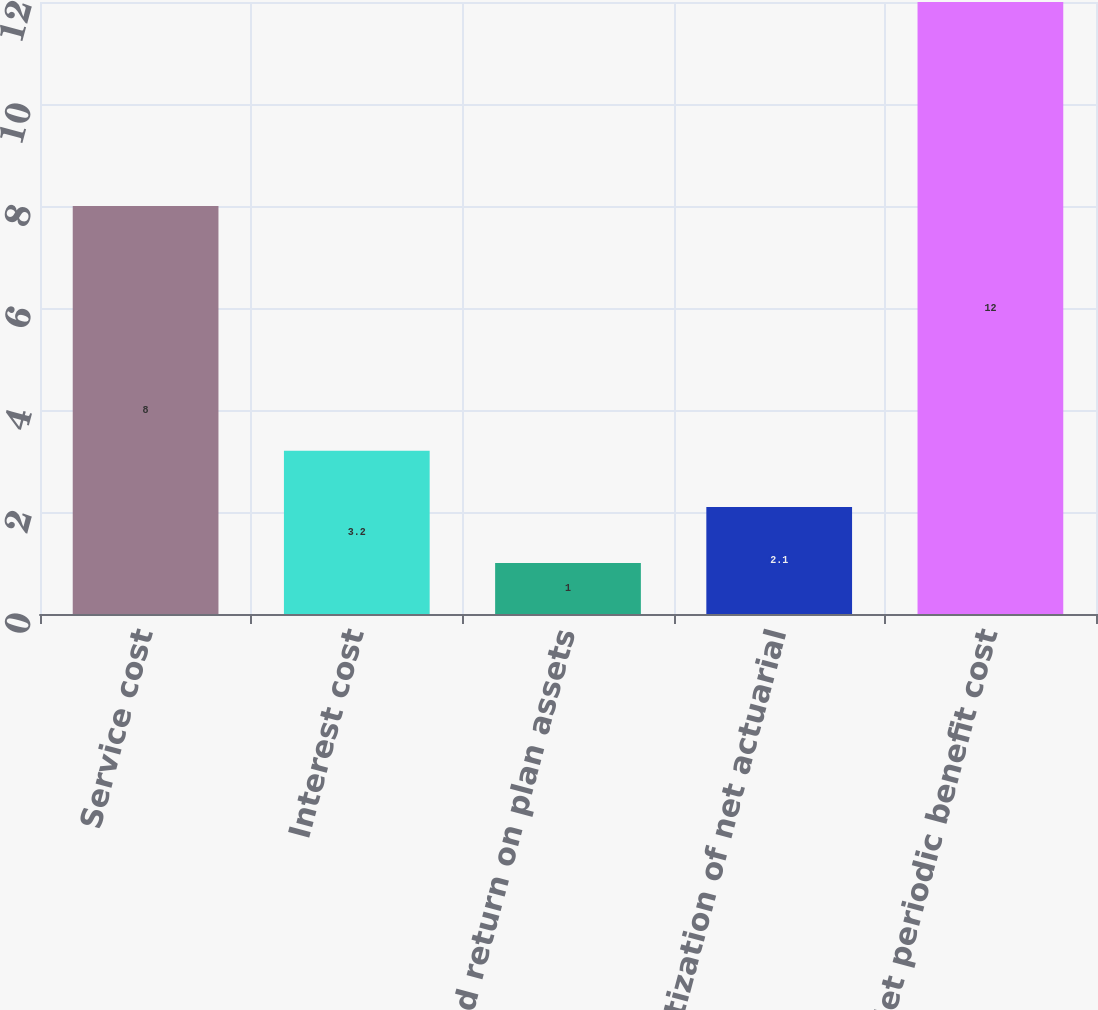Convert chart to OTSL. <chart><loc_0><loc_0><loc_500><loc_500><bar_chart><fcel>Service cost<fcel>Interest cost<fcel>Expected return on plan assets<fcel>Amortization of net actuarial<fcel>Net periodic benefit cost<nl><fcel>8<fcel>3.2<fcel>1<fcel>2.1<fcel>12<nl></chart> 